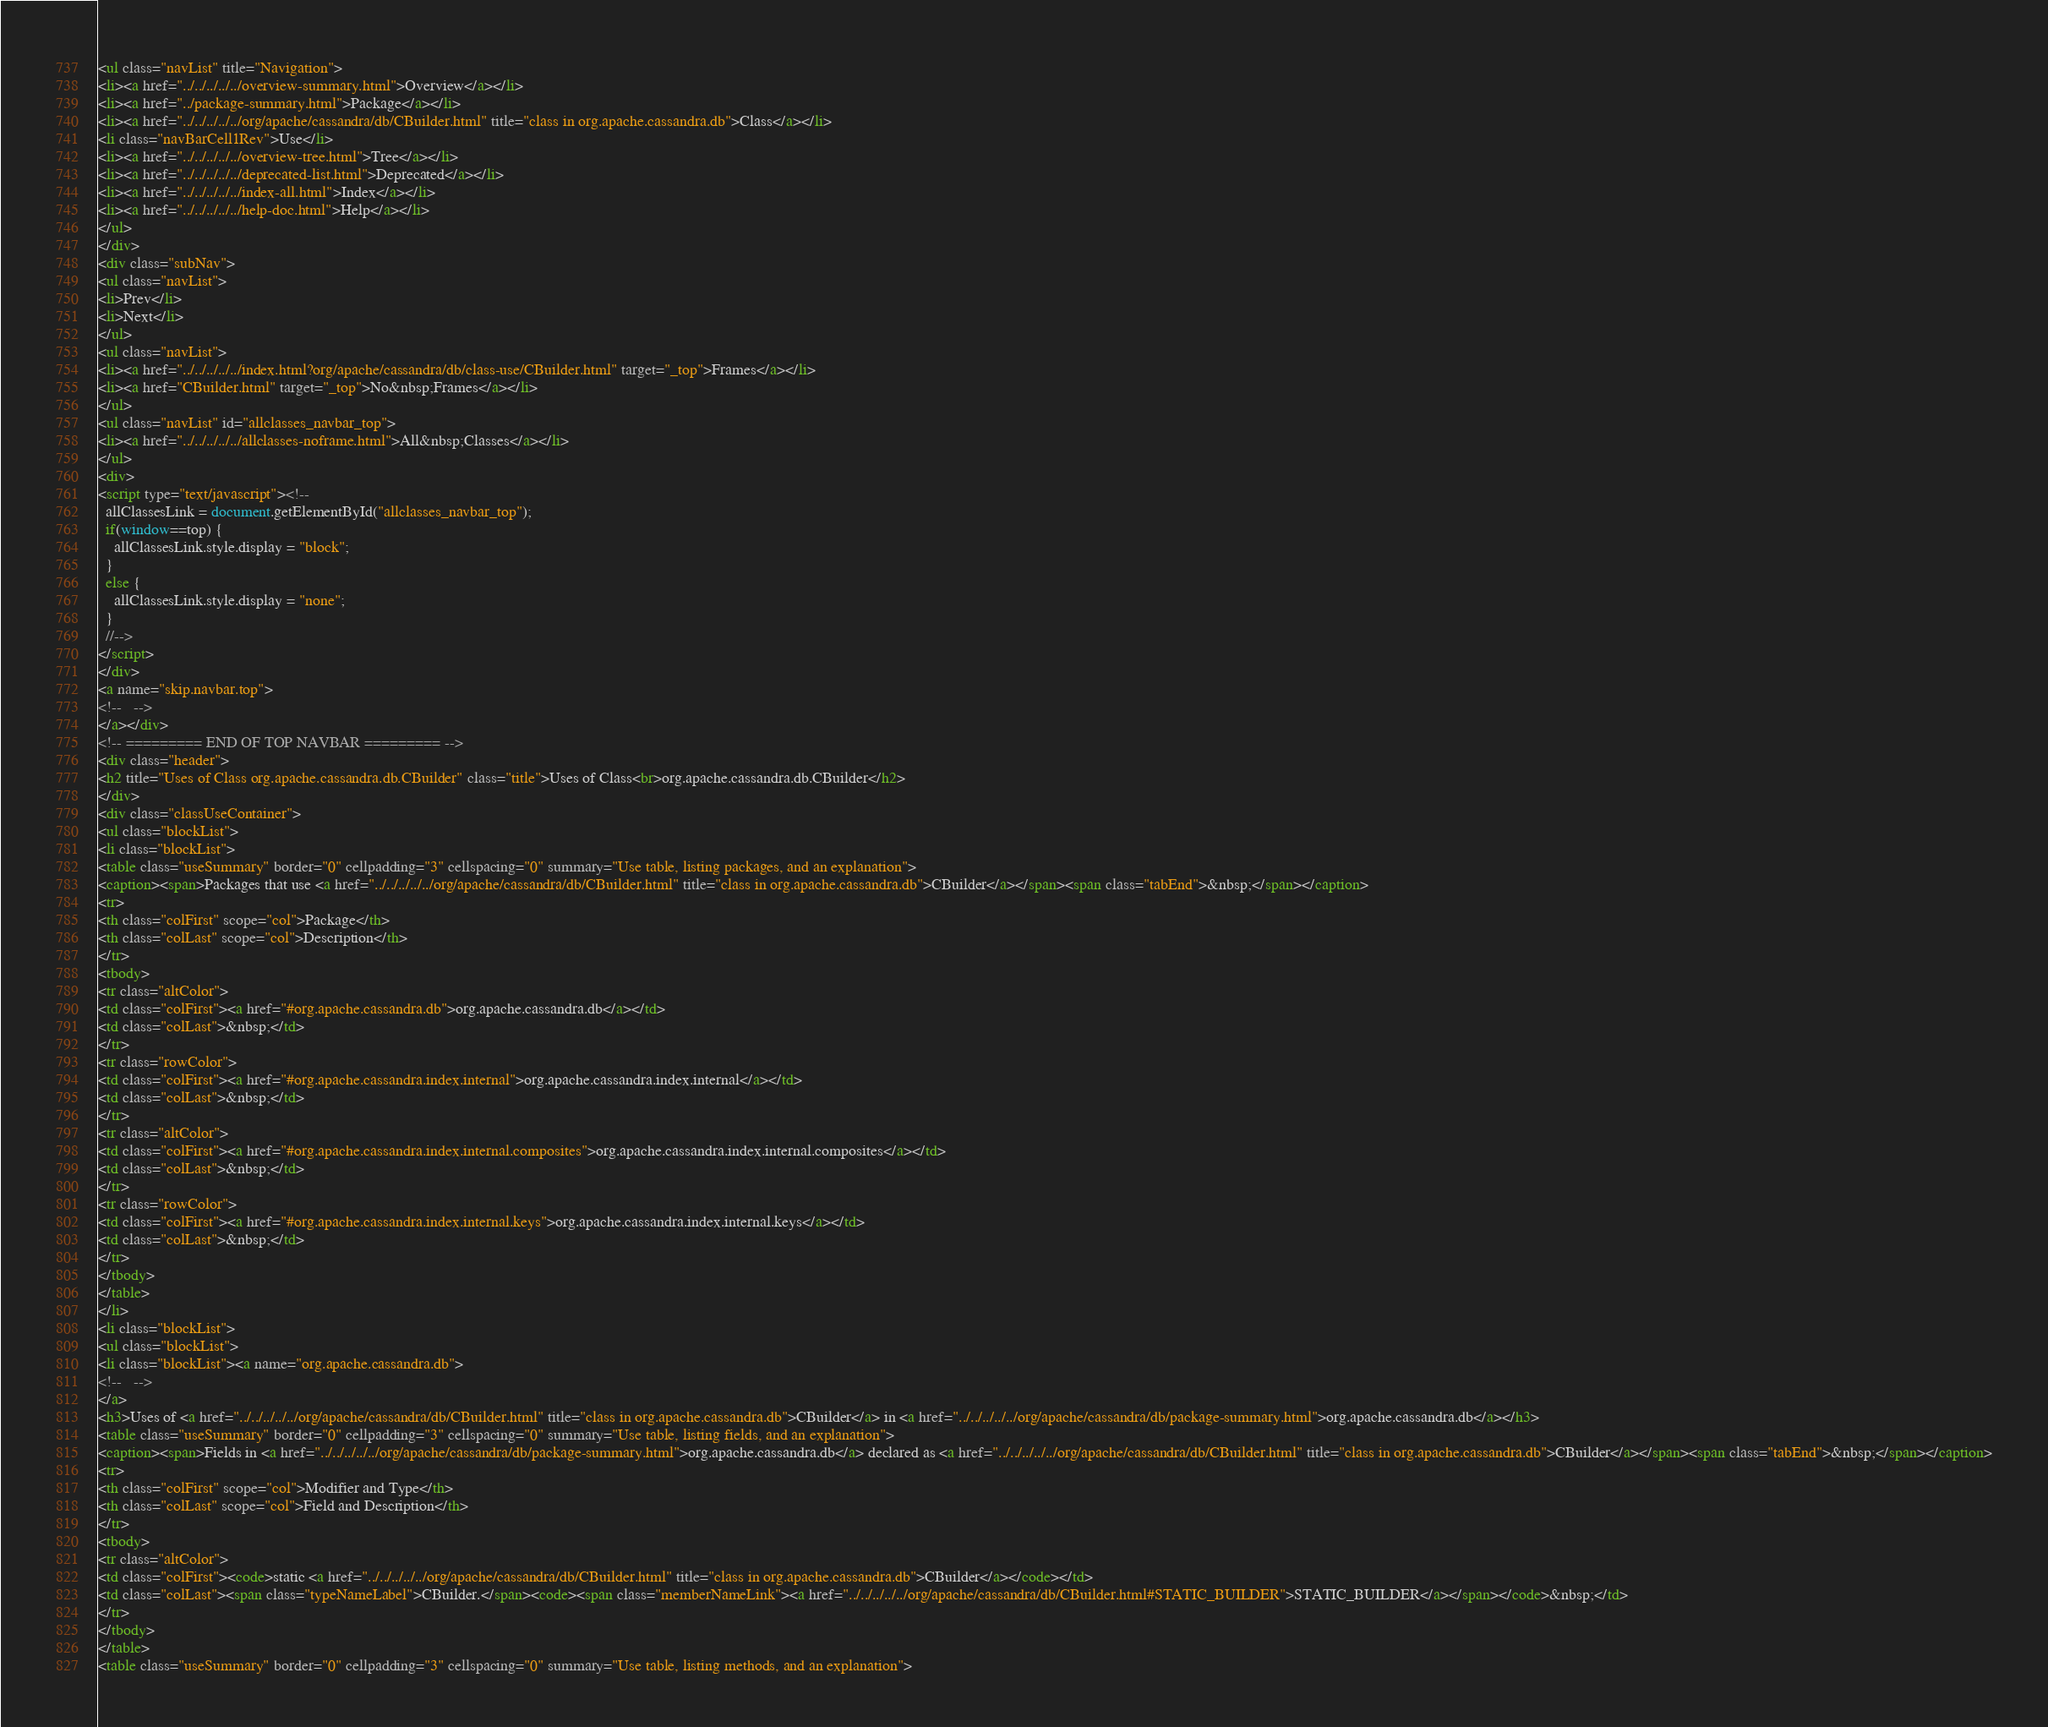<code> <loc_0><loc_0><loc_500><loc_500><_HTML_><ul class="navList" title="Navigation">
<li><a href="../../../../../overview-summary.html">Overview</a></li>
<li><a href="../package-summary.html">Package</a></li>
<li><a href="../../../../../org/apache/cassandra/db/CBuilder.html" title="class in org.apache.cassandra.db">Class</a></li>
<li class="navBarCell1Rev">Use</li>
<li><a href="../../../../../overview-tree.html">Tree</a></li>
<li><a href="../../../../../deprecated-list.html">Deprecated</a></li>
<li><a href="../../../../../index-all.html">Index</a></li>
<li><a href="../../../../../help-doc.html">Help</a></li>
</ul>
</div>
<div class="subNav">
<ul class="navList">
<li>Prev</li>
<li>Next</li>
</ul>
<ul class="navList">
<li><a href="../../../../../index.html?org/apache/cassandra/db/class-use/CBuilder.html" target="_top">Frames</a></li>
<li><a href="CBuilder.html" target="_top">No&nbsp;Frames</a></li>
</ul>
<ul class="navList" id="allclasses_navbar_top">
<li><a href="../../../../../allclasses-noframe.html">All&nbsp;Classes</a></li>
</ul>
<div>
<script type="text/javascript"><!--
  allClassesLink = document.getElementById("allclasses_navbar_top");
  if(window==top) {
    allClassesLink.style.display = "block";
  }
  else {
    allClassesLink.style.display = "none";
  }
  //-->
</script>
</div>
<a name="skip.navbar.top">
<!--   -->
</a></div>
<!-- ========= END OF TOP NAVBAR ========= -->
<div class="header">
<h2 title="Uses of Class org.apache.cassandra.db.CBuilder" class="title">Uses of Class<br>org.apache.cassandra.db.CBuilder</h2>
</div>
<div class="classUseContainer">
<ul class="blockList">
<li class="blockList">
<table class="useSummary" border="0" cellpadding="3" cellspacing="0" summary="Use table, listing packages, and an explanation">
<caption><span>Packages that use <a href="../../../../../org/apache/cassandra/db/CBuilder.html" title="class in org.apache.cassandra.db">CBuilder</a></span><span class="tabEnd">&nbsp;</span></caption>
<tr>
<th class="colFirst" scope="col">Package</th>
<th class="colLast" scope="col">Description</th>
</tr>
<tbody>
<tr class="altColor">
<td class="colFirst"><a href="#org.apache.cassandra.db">org.apache.cassandra.db</a></td>
<td class="colLast">&nbsp;</td>
</tr>
<tr class="rowColor">
<td class="colFirst"><a href="#org.apache.cassandra.index.internal">org.apache.cassandra.index.internal</a></td>
<td class="colLast">&nbsp;</td>
</tr>
<tr class="altColor">
<td class="colFirst"><a href="#org.apache.cassandra.index.internal.composites">org.apache.cassandra.index.internal.composites</a></td>
<td class="colLast">&nbsp;</td>
</tr>
<tr class="rowColor">
<td class="colFirst"><a href="#org.apache.cassandra.index.internal.keys">org.apache.cassandra.index.internal.keys</a></td>
<td class="colLast">&nbsp;</td>
</tr>
</tbody>
</table>
</li>
<li class="blockList">
<ul class="blockList">
<li class="blockList"><a name="org.apache.cassandra.db">
<!--   -->
</a>
<h3>Uses of <a href="../../../../../org/apache/cassandra/db/CBuilder.html" title="class in org.apache.cassandra.db">CBuilder</a> in <a href="../../../../../org/apache/cassandra/db/package-summary.html">org.apache.cassandra.db</a></h3>
<table class="useSummary" border="0" cellpadding="3" cellspacing="0" summary="Use table, listing fields, and an explanation">
<caption><span>Fields in <a href="../../../../../org/apache/cassandra/db/package-summary.html">org.apache.cassandra.db</a> declared as <a href="../../../../../org/apache/cassandra/db/CBuilder.html" title="class in org.apache.cassandra.db">CBuilder</a></span><span class="tabEnd">&nbsp;</span></caption>
<tr>
<th class="colFirst" scope="col">Modifier and Type</th>
<th class="colLast" scope="col">Field and Description</th>
</tr>
<tbody>
<tr class="altColor">
<td class="colFirst"><code>static <a href="../../../../../org/apache/cassandra/db/CBuilder.html" title="class in org.apache.cassandra.db">CBuilder</a></code></td>
<td class="colLast"><span class="typeNameLabel">CBuilder.</span><code><span class="memberNameLink"><a href="../../../../../org/apache/cassandra/db/CBuilder.html#STATIC_BUILDER">STATIC_BUILDER</a></span></code>&nbsp;</td>
</tr>
</tbody>
</table>
<table class="useSummary" border="0" cellpadding="3" cellspacing="0" summary="Use table, listing methods, and an explanation"></code> 